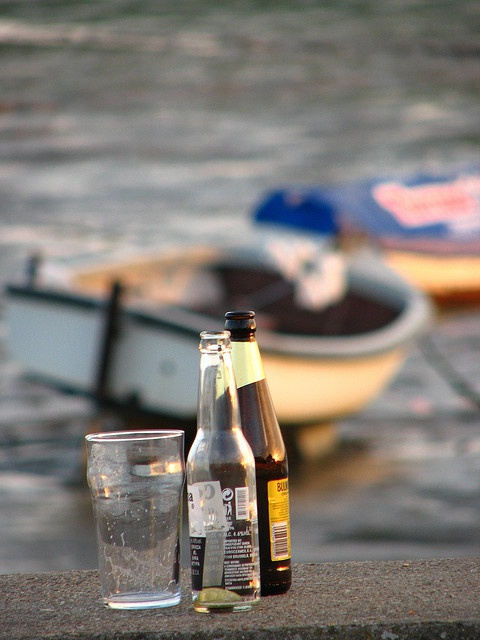Describe the objects in this image and their specific colors. I can see boat in gray, darkgray, black, and tan tones, bottle in gray, darkgray, ivory, and black tones, cup in gray and darkgray tones, bottle in gray, black, maroon, khaki, and orange tones, and boat in gray, tan, and darkgray tones in this image. 